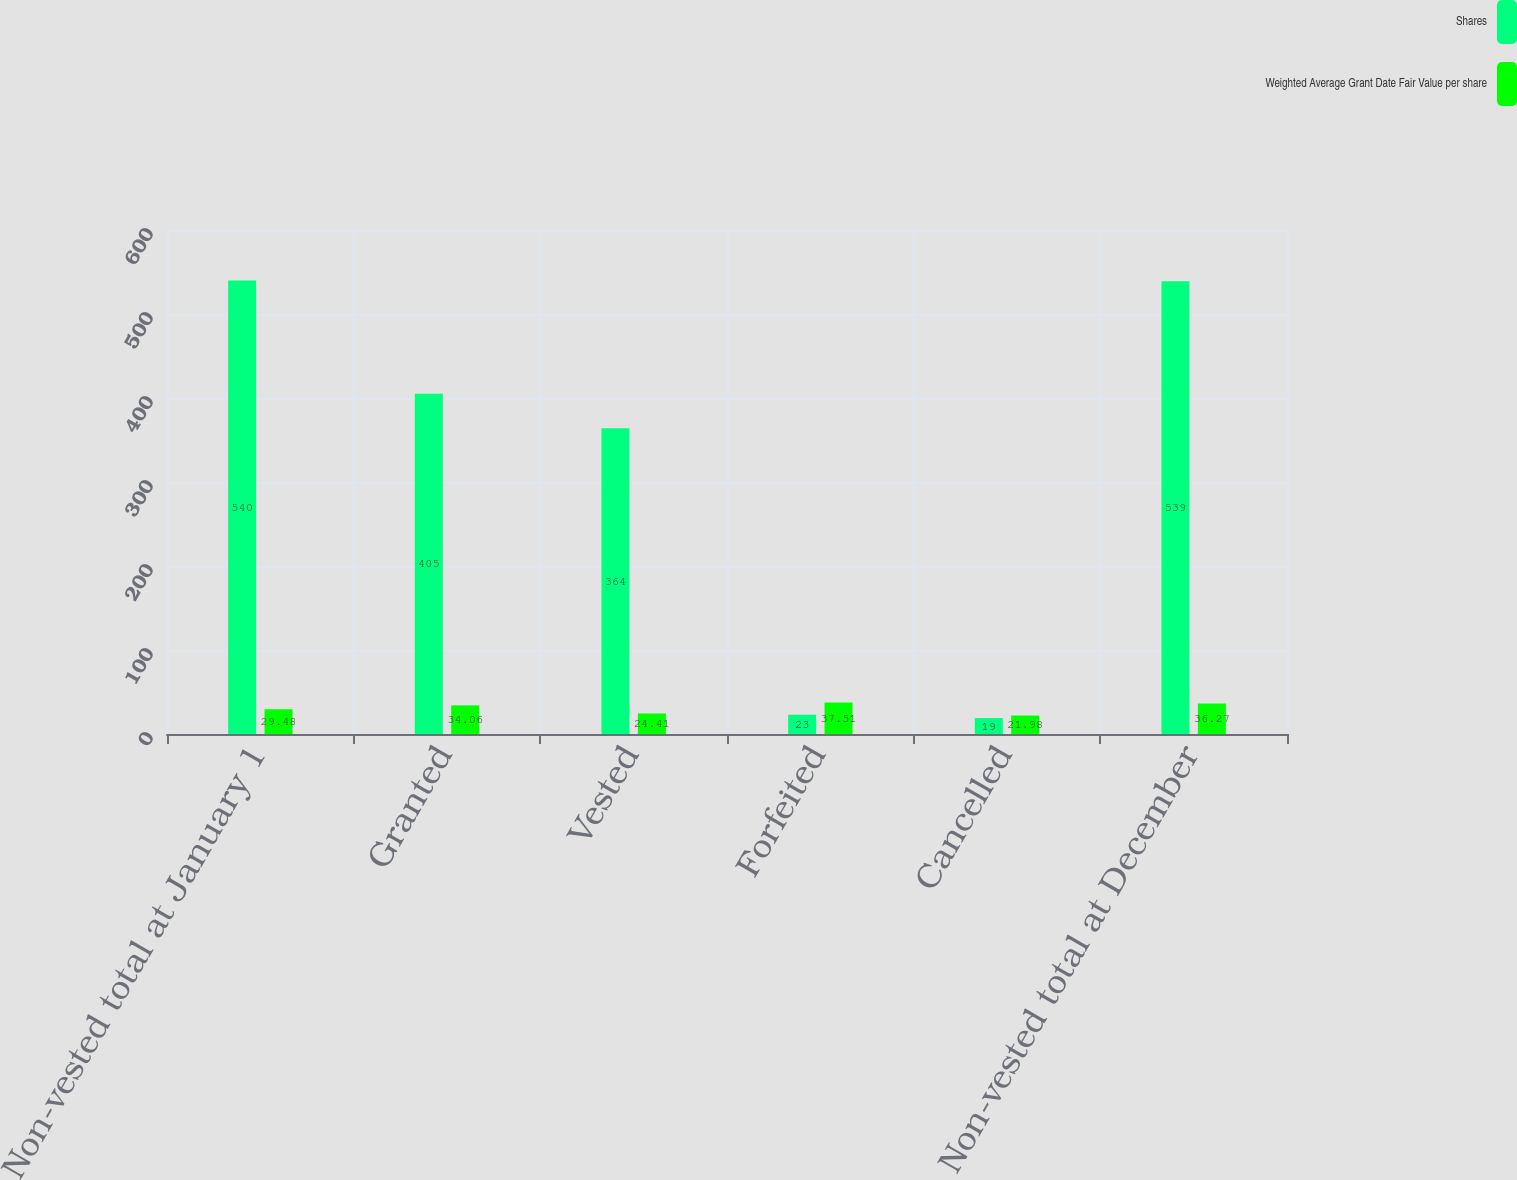Convert chart. <chart><loc_0><loc_0><loc_500><loc_500><stacked_bar_chart><ecel><fcel>Non-vested total at January 1<fcel>Granted<fcel>Vested<fcel>Forfeited<fcel>Cancelled<fcel>Non-vested total at December<nl><fcel>Shares<fcel>540<fcel>405<fcel>364<fcel>23<fcel>19<fcel>539<nl><fcel>Weighted Average Grant Date Fair Value per share<fcel>29.48<fcel>34.06<fcel>24.41<fcel>37.51<fcel>21.98<fcel>36.27<nl></chart> 